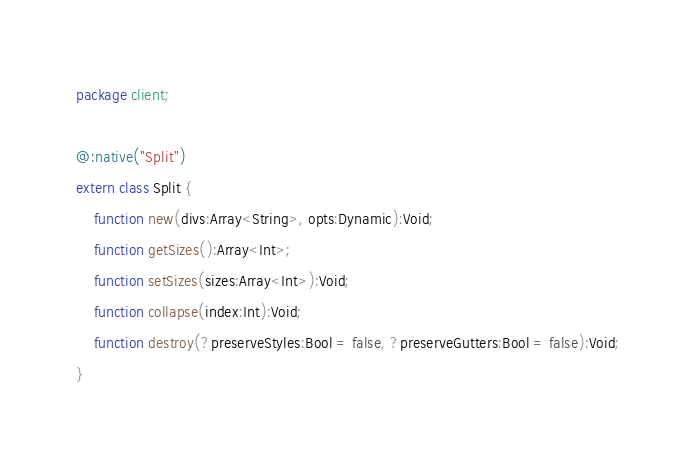Convert code to text. <code><loc_0><loc_0><loc_500><loc_500><_Haxe_>package client;

@:native("Split")
extern class Split {
	function new(divs:Array<String>, opts:Dynamic):Void;
	function getSizes():Array<Int>;
	function setSizes(sizes:Array<Int>):Void;
	function collapse(index:Int):Void;
	function destroy(?preserveStyles:Bool = false, ?preserveGutters:Bool = false):Void;
}
</code> 